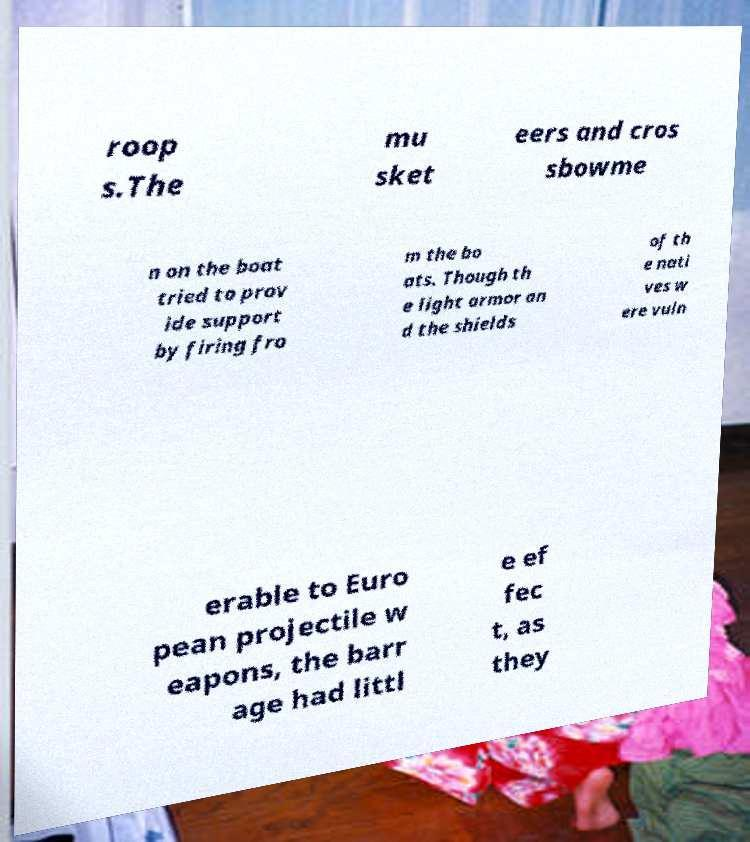For documentation purposes, I need the text within this image transcribed. Could you provide that? roop s.The mu sket eers and cros sbowme n on the boat tried to prov ide support by firing fro m the bo ats. Though th e light armor an d the shields of th e nati ves w ere vuln erable to Euro pean projectile w eapons, the barr age had littl e ef fec t, as they 